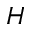<formula> <loc_0><loc_0><loc_500><loc_500>H</formula> 